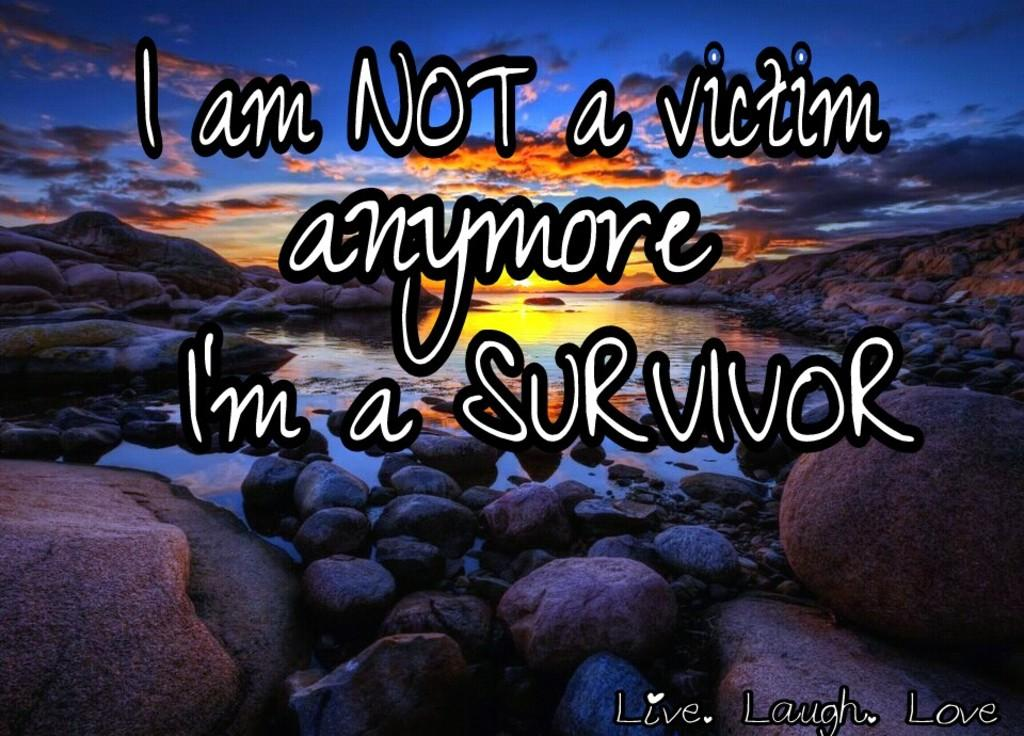Provide a one-sentence caption for the provided image. A sunset with the writing I am not a victim anymore, I'm a survivor. 